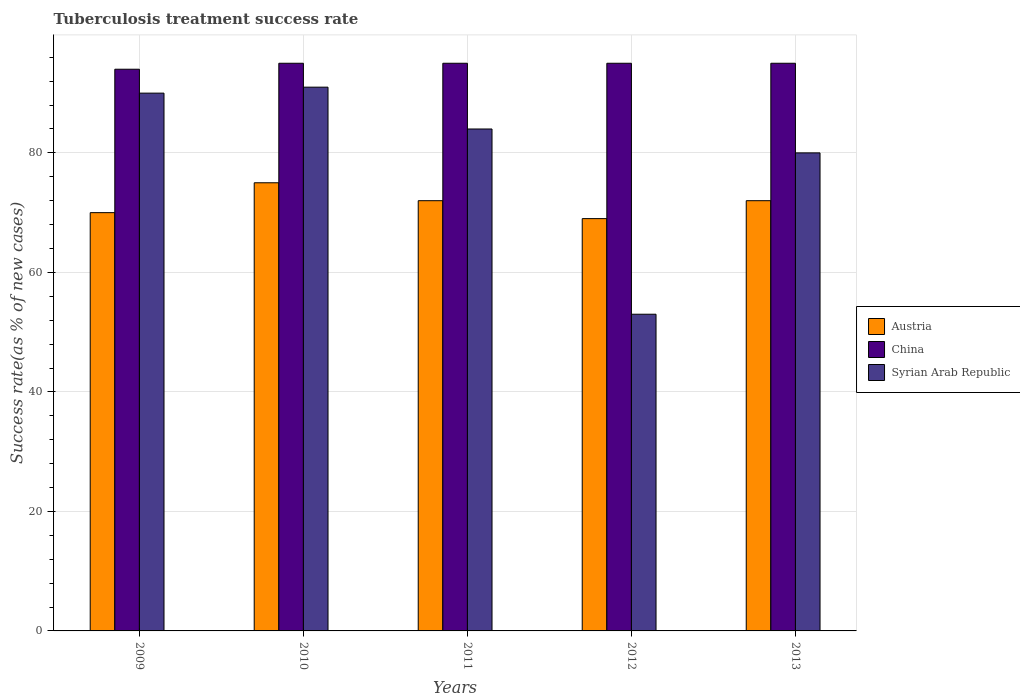How many different coloured bars are there?
Keep it short and to the point. 3. How many bars are there on the 1st tick from the left?
Your answer should be very brief. 3. How many bars are there on the 4th tick from the right?
Give a very brief answer. 3. What is the tuberculosis treatment success rate in Syrian Arab Republic in 2013?
Keep it short and to the point. 80. Across all years, what is the maximum tuberculosis treatment success rate in Syrian Arab Republic?
Your response must be concise. 91. Across all years, what is the minimum tuberculosis treatment success rate in China?
Offer a very short reply. 94. What is the total tuberculosis treatment success rate in Syrian Arab Republic in the graph?
Offer a terse response. 398. What is the difference between the tuberculosis treatment success rate in China in 2009 and that in 2013?
Your answer should be compact. -1. What is the difference between the tuberculosis treatment success rate in China in 2011 and the tuberculosis treatment success rate in Austria in 2012?
Offer a terse response. 26. What is the average tuberculosis treatment success rate in Austria per year?
Offer a terse response. 71.6. What is the ratio of the tuberculosis treatment success rate in Austria in 2010 to that in 2012?
Keep it short and to the point. 1.09. Is the difference between the tuberculosis treatment success rate in China in 2009 and 2010 greater than the difference between the tuberculosis treatment success rate in Austria in 2009 and 2010?
Offer a very short reply. Yes. In how many years, is the tuberculosis treatment success rate in China greater than the average tuberculosis treatment success rate in China taken over all years?
Your answer should be compact. 4. How many bars are there?
Give a very brief answer. 15. What is the difference between two consecutive major ticks on the Y-axis?
Provide a succinct answer. 20. Does the graph contain any zero values?
Keep it short and to the point. No. Does the graph contain grids?
Make the answer very short. Yes. Where does the legend appear in the graph?
Offer a terse response. Center right. How many legend labels are there?
Ensure brevity in your answer.  3. What is the title of the graph?
Offer a terse response. Tuberculosis treatment success rate. What is the label or title of the Y-axis?
Offer a very short reply. Success rate(as % of new cases). What is the Success rate(as % of new cases) in Austria in 2009?
Offer a very short reply. 70. What is the Success rate(as % of new cases) in China in 2009?
Your answer should be very brief. 94. What is the Success rate(as % of new cases) of Austria in 2010?
Provide a succinct answer. 75. What is the Success rate(as % of new cases) of Syrian Arab Republic in 2010?
Offer a terse response. 91. What is the Success rate(as % of new cases) in Austria in 2011?
Your answer should be compact. 72. What is the Success rate(as % of new cases) in China in 2011?
Your response must be concise. 95. What is the Success rate(as % of new cases) of Syrian Arab Republic in 2011?
Your response must be concise. 84. What is the Success rate(as % of new cases) in Austria in 2012?
Give a very brief answer. 69. What is the Success rate(as % of new cases) in Austria in 2013?
Your answer should be compact. 72. Across all years, what is the maximum Success rate(as % of new cases) of Syrian Arab Republic?
Offer a terse response. 91. Across all years, what is the minimum Success rate(as % of new cases) in Austria?
Your answer should be compact. 69. Across all years, what is the minimum Success rate(as % of new cases) in China?
Give a very brief answer. 94. What is the total Success rate(as % of new cases) of Austria in the graph?
Keep it short and to the point. 358. What is the total Success rate(as % of new cases) of China in the graph?
Ensure brevity in your answer.  474. What is the total Success rate(as % of new cases) in Syrian Arab Republic in the graph?
Your answer should be very brief. 398. What is the difference between the Success rate(as % of new cases) of Austria in 2009 and that in 2010?
Provide a succinct answer. -5. What is the difference between the Success rate(as % of new cases) of China in 2009 and that in 2010?
Keep it short and to the point. -1. What is the difference between the Success rate(as % of new cases) in Syrian Arab Republic in 2009 and that in 2010?
Keep it short and to the point. -1. What is the difference between the Success rate(as % of new cases) in Austria in 2009 and that in 2011?
Provide a succinct answer. -2. What is the difference between the Success rate(as % of new cases) of Syrian Arab Republic in 2009 and that in 2012?
Your answer should be very brief. 37. What is the difference between the Success rate(as % of new cases) in Austria in 2009 and that in 2013?
Ensure brevity in your answer.  -2. What is the difference between the Success rate(as % of new cases) of China in 2009 and that in 2013?
Ensure brevity in your answer.  -1. What is the difference between the Success rate(as % of new cases) of Syrian Arab Republic in 2009 and that in 2013?
Offer a terse response. 10. What is the difference between the Success rate(as % of new cases) in Austria in 2010 and that in 2011?
Your response must be concise. 3. What is the difference between the Success rate(as % of new cases) of China in 2010 and that in 2011?
Provide a short and direct response. 0. What is the difference between the Success rate(as % of new cases) of Syrian Arab Republic in 2010 and that in 2011?
Make the answer very short. 7. What is the difference between the Success rate(as % of new cases) of Austria in 2010 and that in 2012?
Offer a terse response. 6. What is the difference between the Success rate(as % of new cases) of China in 2010 and that in 2012?
Your answer should be very brief. 0. What is the difference between the Success rate(as % of new cases) in Syrian Arab Republic in 2010 and that in 2012?
Offer a very short reply. 38. What is the difference between the Success rate(as % of new cases) in Austria in 2010 and that in 2013?
Your response must be concise. 3. What is the difference between the Success rate(as % of new cases) in Austria in 2011 and that in 2012?
Provide a short and direct response. 3. What is the difference between the Success rate(as % of new cases) of Syrian Arab Republic in 2011 and that in 2012?
Offer a very short reply. 31. What is the difference between the Success rate(as % of new cases) in China in 2011 and that in 2013?
Ensure brevity in your answer.  0. What is the difference between the Success rate(as % of new cases) in Austria in 2012 and that in 2013?
Provide a succinct answer. -3. What is the difference between the Success rate(as % of new cases) in China in 2012 and that in 2013?
Give a very brief answer. 0. What is the difference between the Success rate(as % of new cases) of Syrian Arab Republic in 2012 and that in 2013?
Give a very brief answer. -27. What is the difference between the Success rate(as % of new cases) of Austria in 2009 and the Success rate(as % of new cases) of China in 2010?
Ensure brevity in your answer.  -25. What is the difference between the Success rate(as % of new cases) of Austria in 2009 and the Success rate(as % of new cases) of Syrian Arab Republic in 2010?
Ensure brevity in your answer.  -21. What is the difference between the Success rate(as % of new cases) in Austria in 2009 and the Success rate(as % of new cases) in China in 2011?
Ensure brevity in your answer.  -25. What is the difference between the Success rate(as % of new cases) of Austria in 2009 and the Success rate(as % of new cases) of Syrian Arab Republic in 2011?
Your answer should be very brief. -14. What is the difference between the Success rate(as % of new cases) of Austria in 2009 and the Success rate(as % of new cases) of China in 2012?
Give a very brief answer. -25. What is the difference between the Success rate(as % of new cases) of Austria in 2009 and the Success rate(as % of new cases) of Syrian Arab Republic in 2012?
Your answer should be very brief. 17. What is the difference between the Success rate(as % of new cases) in Austria in 2009 and the Success rate(as % of new cases) in China in 2013?
Keep it short and to the point. -25. What is the difference between the Success rate(as % of new cases) in Austria in 2009 and the Success rate(as % of new cases) in Syrian Arab Republic in 2013?
Offer a very short reply. -10. What is the difference between the Success rate(as % of new cases) in China in 2009 and the Success rate(as % of new cases) in Syrian Arab Republic in 2013?
Your response must be concise. 14. What is the difference between the Success rate(as % of new cases) of Austria in 2010 and the Success rate(as % of new cases) of China in 2011?
Provide a succinct answer. -20. What is the difference between the Success rate(as % of new cases) in Austria in 2010 and the Success rate(as % of new cases) in Syrian Arab Republic in 2011?
Offer a very short reply. -9. What is the difference between the Success rate(as % of new cases) of China in 2010 and the Success rate(as % of new cases) of Syrian Arab Republic in 2011?
Ensure brevity in your answer.  11. What is the difference between the Success rate(as % of new cases) in Austria in 2011 and the Success rate(as % of new cases) in Syrian Arab Republic in 2012?
Keep it short and to the point. 19. What is the difference between the Success rate(as % of new cases) of Austria in 2011 and the Success rate(as % of new cases) of China in 2013?
Your answer should be very brief. -23. What is the difference between the Success rate(as % of new cases) in Austria in 2011 and the Success rate(as % of new cases) in Syrian Arab Republic in 2013?
Offer a very short reply. -8. What is the difference between the Success rate(as % of new cases) in China in 2011 and the Success rate(as % of new cases) in Syrian Arab Republic in 2013?
Give a very brief answer. 15. What is the average Success rate(as % of new cases) of Austria per year?
Your response must be concise. 71.6. What is the average Success rate(as % of new cases) of China per year?
Offer a very short reply. 94.8. What is the average Success rate(as % of new cases) of Syrian Arab Republic per year?
Offer a terse response. 79.6. In the year 2009, what is the difference between the Success rate(as % of new cases) in Austria and Success rate(as % of new cases) in China?
Make the answer very short. -24. In the year 2009, what is the difference between the Success rate(as % of new cases) of China and Success rate(as % of new cases) of Syrian Arab Republic?
Give a very brief answer. 4. In the year 2010, what is the difference between the Success rate(as % of new cases) in Austria and Success rate(as % of new cases) in China?
Make the answer very short. -20. In the year 2010, what is the difference between the Success rate(as % of new cases) of Austria and Success rate(as % of new cases) of Syrian Arab Republic?
Offer a very short reply. -16. In the year 2011, what is the difference between the Success rate(as % of new cases) of Austria and Success rate(as % of new cases) of China?
Your response must be concise. -23. In the year 2011, what is the difference between the Success rate(as % of new cases) of Austria and Success rate(as % of new cases) of Syrian Arab Republic?
Make the answer very short. -12. In the year 2012, what is the difference between the Success rate(as % of new cases) in Austria and Success rate(as % of new cases) in China?
Keep it short and to the point. -26. In the year 2012, what is the difference between the Success rate(as % of new cases) in China and Success rate(as % of new cases) in Syrian Arab Republic?
Provide a succinct answer. 42. In the year 2013, what is the difference between the Success rate(as % of new cases) of Austria and Success rate(as % of new cases) of Syrian Arab Republic?
Keep it short and to the point. -8. In the year 2013, what is the difference between the Success rate(as % of new cases) in China and Success rate(as % of new cases) in Syrian Arab Republic?
Ensure brevity in your answer.  15. What is the ratio of the Success rate(as % of new cases) in Austria in 2009 to that in 2010?
Give a very brief answer. 0.93. What is the ratio of the Success rate(as % of new cases) of Syrian Arab Republic in 2009 to that in 2010?
Your response must be concise. 0.99. What is the ratio of the Success rate(as % of new cases) of Austria in 2009 to that in 2011?
Give a very brief answer. 0.97. What is the ratio of the Success rate(as % of new cases) in Syrian Arab Republic in 2009 to that in 2011?
Keep it short and to the point. 1.07. What is the ratio of the Success rate(as % of new cases) in Austria in 2009 to that in 2012?
Keep it short and to the point. 1.01. What is the ratio of the Success rate(as % of new cases) of Syrian Arab Republic in 2009 to that in 2012?
Offer a very short reply. 1.7. What is the ratio of the Success rate(as % of new cases) in Austria in 2009 to that in 2013?
Ensure brevity in your answer.  0.97. What is the ratio of the Success rate(as % of new cases) of China in 2009 to that in 2013?
Give a very brief answer. 0.99. What is the ratio of the Success rate(as % of new cases) of Syrian Arab Republic in 2009 to that in 2013?
Give a very brief answer. 1.12. What is the ratio of the Success rate(as % of new cases) in Austria in 2010 to that in 2011?
Provide a short and direct response. 1.04. What is the ratio of the Success rate(as % of new cases) of China in 2010 to that in 2011?
Your answer should be compact. 1. What is the ratio of the Success rate(as % of new cases) in Syrian Arab Republic in 2010 to that in 2011?
Your response must be concise. 1.08. What is the ratio of the Success rate(as % of new cases) of Austria in 2010 to that in 2012?
Give a very brief answer. 1.09. What is the ratio of the Success rate(as % of new cases) in China in 2010 to that in 2012?
Your answer should be very brief. 1. What is the ratio of the Success rate(as % of new cases) in Syrian Arab Republic in 2010 to that in 2012?
Provide a succinct answer. 1.72. What is the ratio of the Success rate(as % of new cases) of Austria in 2010 to that in 2013?
Make the answer very short. 1.04. What is the ratio of the Success rate(as % of new cases) in China in 2010 to that in 2013?
Your answer should be very brief. 1. What is the ratio of the Success rate(as % of new cases) of Syrian Arab Republic in 2010 to that in 2013?
Offer a very short reply. 1.14. What is the ratio of the Success rate(as % of new cases) of Austria in 2011 to that in 2012?
Ensure brevity in your answer.  1.04. What is the ratio of the Success rate(as % of new cases) of China in 2011 to that in 2012?
Give a very brief answer. 1. What is the ratio of the Success rate(as % of new cases) of Syrian Arab Republic in 2011 to that in 2012?
Make the answer very short. 1.58. What is the ratio of the Success rate(as % of new cases) of China in 2011 to that in 2013?
Give a very brief answer. 1. What is the ratio of the Success rate(as % of new cases) of China in 2012 to that in 2013?
Make the answer very short. 1. What is the ratio of the Success rate(as % of new cases) in Syrian Arab Republic in 2012 to that in 2013?
Ensure brevity in your answer.  0.66. 